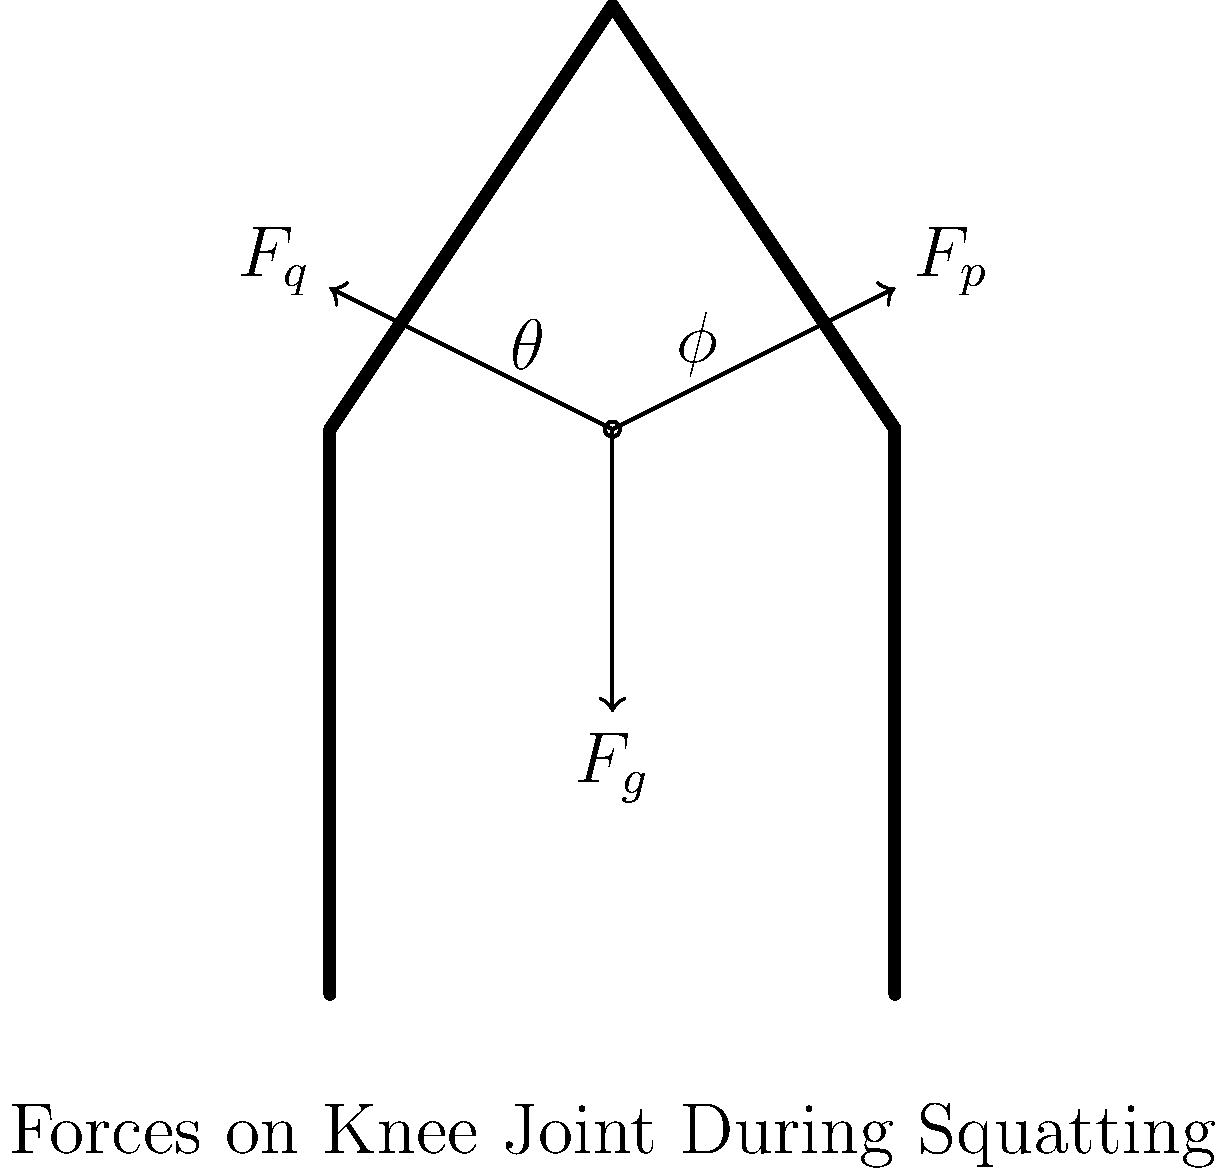In the diagram above, which force vector represents the weight of the upper body acting on the knee joint during a squat, and how does this force change as the squat depth increases? To answer this question, let's break it down step-by-step:

1. Force identification:
   - $F_g$ represents the gravitational force (weight of the upper body)
   - $F_q$ represents the quadriceps muscle force
   - $F_p$ represents the patellar tendon force

2. Weight force:
   The force vector $F_g$ represents the weight of the upper body acting on the knee joint during a squat.

3. Squat depth and force changes:
   As the squat depth increases:
   a) The angle $\theta$ (between the femur and the vertical) increases
   b) The moment arm of $F_g$ about the knee joint increases
   c) To maintain balance, the magnitude of $F_g$ remains constant, but its effect on the knee joint increases

4. Biomechanical implications:
   - Increased squat depth leads to greater torque at the knee joint
   - This requires stronger contraction of the quadriceps muscle (increasing $F_q$)
   - The increased $F_q$ leads to a larger patellar tendon force ($F_p$)

5. Practical considerations for a mechanic:
   - This principle is similar to the increased force required to hold a wrench further from the bolt
   - Understanding these forces can help in designing ergonomic workspaces and preventing knee injuries during work-related squatting
Answer: $F_g$ represents the weight; it increases its effect on the knee as squat depth increases. 